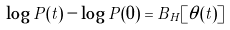<formula> <loc_0><loc_0><loc_500><loc_500>\log { P ( t ) } - \log { P ( 0 ) } = B _ { H } [ \theta ( t ) ] \\</formula> 